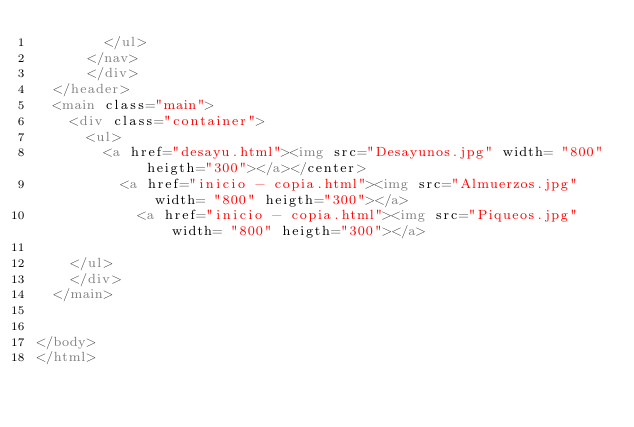Convert code to text. <code><loc_0><loc_0><loc_500><loc_500><_HTML_>				</ul>
			</nav>
			</div>		
	</header>
	<main class="main">
		<div class="container">
			<ul>
				<a href="desayu.html"><img src="Desayunos.jpg" width= "800" heigth="300"></a></center>
			   	<a href="inicio - copia.html"><img src="Almuerzos.jpg" width= "800" heigth="300"></a>
			    	<a href="inicio - copia.html"><img src="Piqueos.jpg" width= "800" heigth="300"></a>
			    
		</ul>
		</div>
	</main>


</body>
</html></code> 